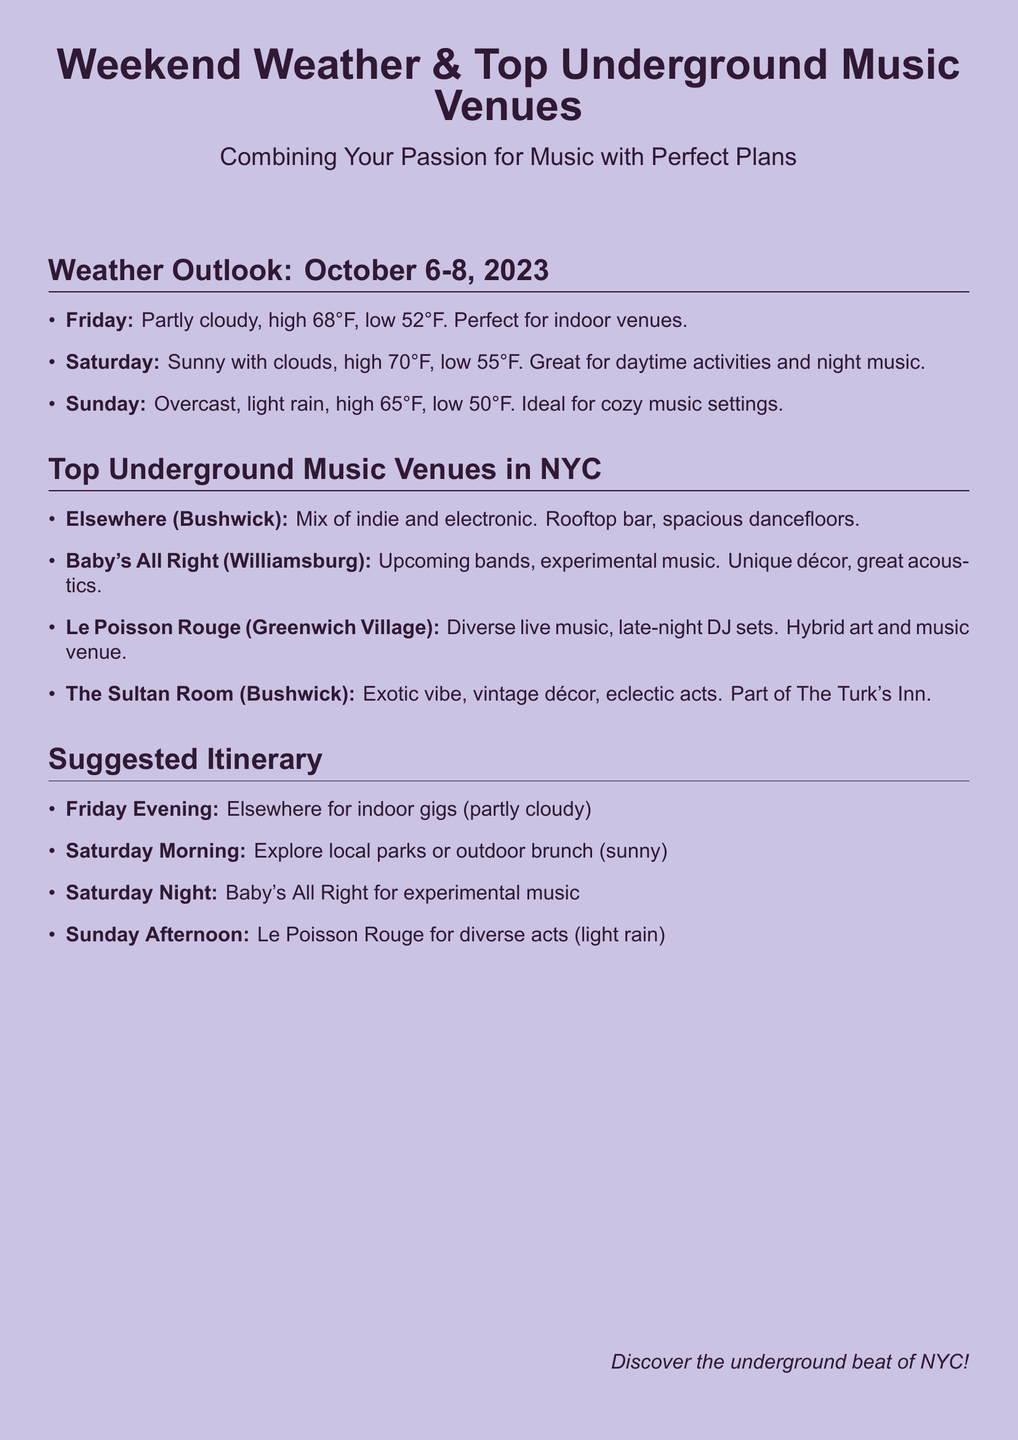What is the high temperature on Saturday? The high temperature for Saturday is stated in the weather outlook section of the document.
Answer: 70°F What venue is located in Bushwick? The document lists multiple venues, and several of them are in Bushwick.
Answer: Elsewhere, The Sultan Room What is the weather like on Friday? The weather forecast for Friday includes cloudiness and temperature information.
Answer: Partly cloudy Which venue offers a mix of indie and electronic music? The document provides descriptions of the venues, including the types of music they feature.
Answer: Elsewhere What should you do on Sunday afternoon? The suggested itinerary outlines activities for each day, including Sunday.
Answer: Le Poisson Rouge for diverse acts What is the low temperature for Sunday? The low temperature for Sunday is clearly stated in the weather outlook section.
Answer: 50°F What type of music is featured at Baby's All Right? The description of Baby's All Right in the document mentions specific music genres.
Answer: Experimental music Which day is ideal for cozy music settings? The weather conditions influencing this activity are detailed in the forecast.
Answer: Sunday 